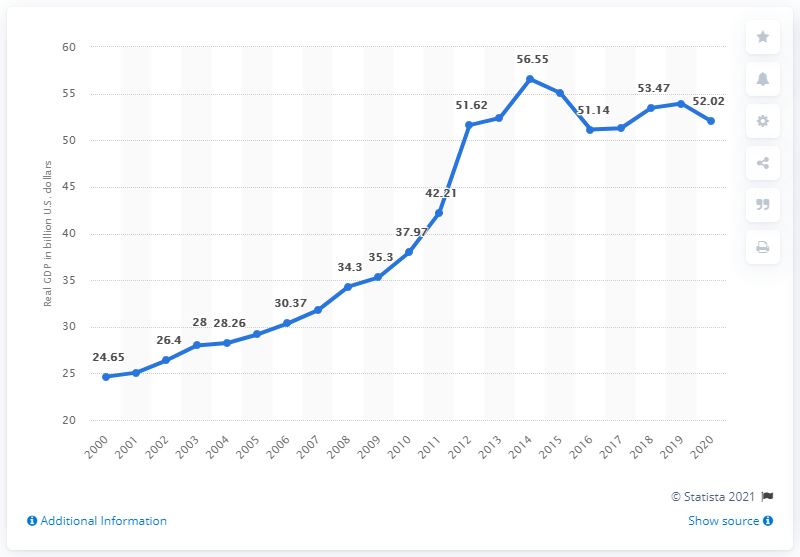Draw attention to some important aspects in this diagram. The real GDP of North Dakota in 2020 was $52.02 billion. 